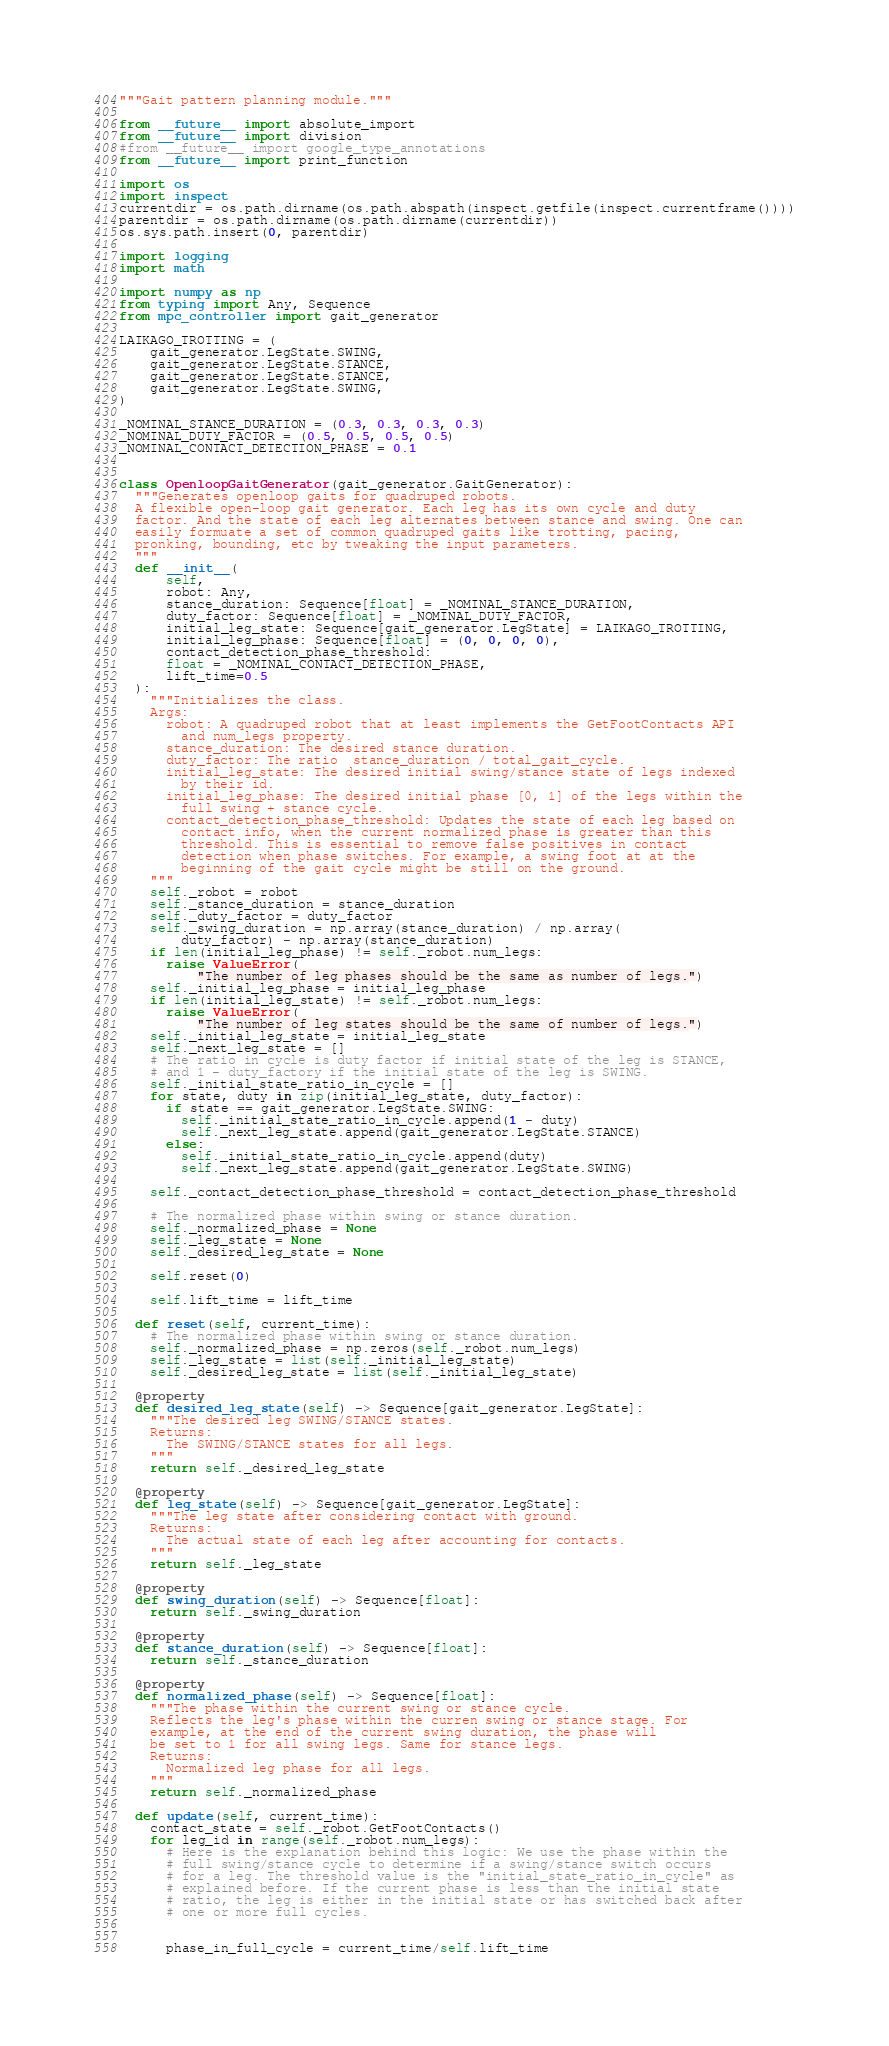Convert code to text. <code><loc_0><loc_0><loc_500><loc_500><_Python_>"""Gait pattern planning module."""

from __future__ import absolute_import
from __future__ import division
#from __future__ import google_type_annotations
from __future__ import print_function

import os
import inspect
currentdir = os.path.dirname(os.path.abspath(inspect.getfile(inspect.currentframe())))
parentdir = os.path.dirname(os.path.dirname(currentdir))
os.sys.path.insert(0, parentdir)

import logging
import math

import numpy as np
from typing import Any, Sequence
from mpc_controller import gait_generator

LAIKAGO_TROTTING = (
    gait_generator.LegState.SWING,
    gait_generator.LegState.STANCE,
    gait_generator.LegState.STANCE,
    gait_generator.LegState.SWING,
)

_NOMINAL_STANCE_DURATION = (0.3, 0.3, 0.3, 0.3)
_NOMINAL_DUTY_FACTOR = (0.5, 0.5, 0.5, 0.5)
_NOMINAL_CONTACT_DETECTION_PHASE = 0.1


class OpenloopGaitGenerator(gait_generator.GaitGenerator):
  """Generates openloop gaits for quadruped robots.
  A flexible open-loop gait generator. Each leg has its own cycle and duty
  factor. And the state of each leg alternates between stance and swing. One can
  easily formuate a set of common quadruped gaits like trotting, pacing,
  pronking, bounding, etc by tweaking the input parameters.
  """
  def __init__(
      self,
      robot: Any,
      stance_duration: Sequence[float] = _NOMINAL_STANCE_DURATION,
      duty_factor: Sequence[float] = _NOMINAL_DUTY_FACTOR,
      initial_leg_state: Sequence[gait_generator.LegState] = LAIKAGO_TROTTING,
      initial_leg_phase: Sequence[float] = (0, 0, 0, 0),
      contact_detection_phase_threshold:
      float = _NOMINAL_CONTACT_DETECTION_PHASE,
      lift_time=0.5
  ):
    """Initializes the class.
    Args:
      robot: A quadruped robot that at least implements the GetFootContacts API
        and num_legs property.
      stance_duration: The desired stance duration.
      duty_factor: The ratio  stance_duration / total_gait_cycle.
      initial_leg_state: The desired initial swing/stance state of legs indexed
        by their id.
      initial_leg_phase: The desired initial phase [0, 1] of the legs within the
        full swing + stance cycle.
      contact_detection_phase_threshold: Updates the state of each leg based on
        contact info, when the current normalized phase is greater than this
        threshold. This is essential to remove false positives in contact
        detection when phase switches. For example, a swing foot at at the
        beginning of the gait cycle might be still on the ground.
    """
    self._robot = robot
    self._stance_duration = stance_duration
    self._duty_factor = duty_factor
    self._swing_duration = np.array(stance_duration) / np.array(
        duty_factor) - np.array(stance_duration)
    if len(initial_leg_phase) != self._robot.num_legs:
      raise ValueError(
          "The number of leg phases should be the same as number of legs.")
    self._initial_leg_phase = initial_leg_phase
    if len(initial_leg_state) != self._robot.num_legs:
      raise ValueError(
          "The number of leg states should be the same of number of legs.")
    self._initial_leg_state = initial_leg_state
    self._next_leg_state = []
    # The ratio in cycle is duty factor if initial state of the leg is STANCE,
    # and 1 - duty_factory if the initial state of the leg is SWING.
    self._initial_state_ratio_in_cycle = []
    for state, duty in zip(initial_leg_state, duty_factor):
      if state == gait_generator.LegState.SWING:
        self._initial_state_ratio_in_cycle.append(1 - duty)
        self._next_leg_state.append(gait_generator.LegState.STANCE)
      else:
        self._initial_state_ratio_in_cycle.append(duty)
        self._next_leg_state.append(gait_generator.LegState.SWING)

    self._contact_detection_phase_threshold = contact_detection_phase_threshold

    # The normalized phase within swing or stance duration.
    self._normalized_phase = None
    self._leg_state = None
    self._desired_leg_state = None

    self.reset(0)

    self.lift_time = lift_time

  def reset(self, current_time):
    # The normalized phase within swing or stance duration.
    self._normalized_phase = np.zeros(self._robot.num_legs)
    self._leg_state = list(self._initial_leg_state)
    self._desired_leg_state = list(self._initial_leg_state)

  @property
  def desired_leg_state(self) -> Sequence[gait_generator.LegState]:
    """The desired leg SWING/STANCE states.
    Returns:
      The SWING/STANCE states for all legs.
    """
    return self._desired_leg_state

  @property
  def leg_state(self) -> Sequence[gait_generator.LegState]:
    """The leg state after considering contact with ground.
    Returns:
      The actual state of each leg after accounting for contacts.
    """
    return self._leg_state

  @property
  def swing_duration(self) -> Sequence[float]:
    return self._swing_duration

  @property
  def stance_duration(self) -> Sequence[float]:
    return self._stance_duration

  @property
  def normalized_phase(self) -> Sequence[float]:
    """The phase within the current swing or stance cycle.
    Reflects the leg's phase within the curren swing or stance stage. For
    example, at the end of the current swing duration, the phase will
    be set to 1 for all swing legs. Same for stance legs.
    Returns:
      Normalized leg phase for all legs.
    """
    return self._normalized_phase

  def update(self, current_time):
    contact_state = self._robot.GetFootContacts()
    for leg_id in range(self._robot.num_legs):
      # Here is the explanation behind this logic: We use the phase within the
      # full swing/stance cycle to determine if a swing/stance switch occurs
      # for a leg. The threshold value is the "initial_state_ratio_in_cycle" as
      # explained before. If the current phase is less than the initial state
      # ratio, the leg is either in the initial state or has switched back after
      # one or more full cycles.


      phase_in_full_cycle = current_time/self.lift_time
</code> 